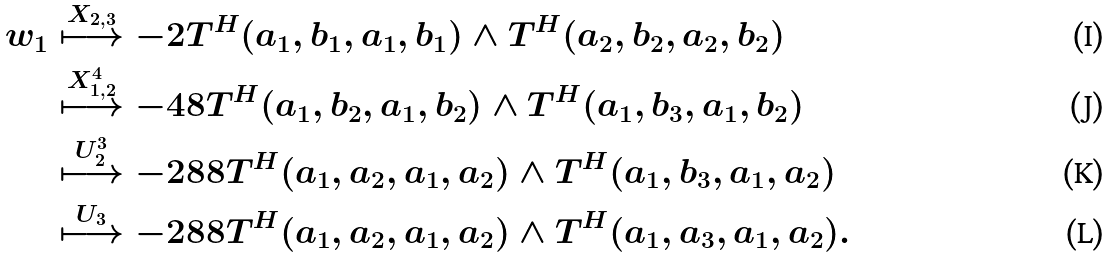Convert formula to latex. <formula><loc_0><loc_0><loc_500><loc_500>w _ { 1 } & \stackrel { X _ { 2 , 3 } } { \longmapsto } - 2 T ^ { H } ( a _ { 1 } , b _ { 1 } , a _ { 1 } , b _ { 1 } ) \wedge T ^ { H } ( a _ { 2 } , b _ { 2 } , a _ { 2 } , b _ { 2 } ) \\ & \stackrel { X _ { 1 , 2 } ^ { 4 } } { \longmapsto } - 4 8 T ^ { H } ( a _ { 1 } , b _ { 2 } , a _ { 1 } , b _ { 2 } ) \wedge T ^ { H } ( a _ { 1 } , b _ { 3 } , a _ { 1 } , b _ { 2 } ) \\ & \stackrel { U _ { 2 } ^ { 3 } } { \longmapsto } - 2 8 8 T ^ { H } ( a _ { 1 } , a _ { 2 } , a _ { 1 } , a _ { 2 } ) \wedge T ^ { H } ( a _ { 1 } , b _ { 3 } , a _ { 1 } , a _ { 2 } ) \\ & \stackrel { U _ { 3 } } { \longmapsto } - 2 8 8 T ^ { H } ( a _ { 1 } , a _ { 2 } , a _ { 1 } , a _ { 2 } ) \wedge T ^ { H } ( a _ { 1 } , a _ { 3 } , a _ { 1 } , a _ { 2 } ) .</formula> 